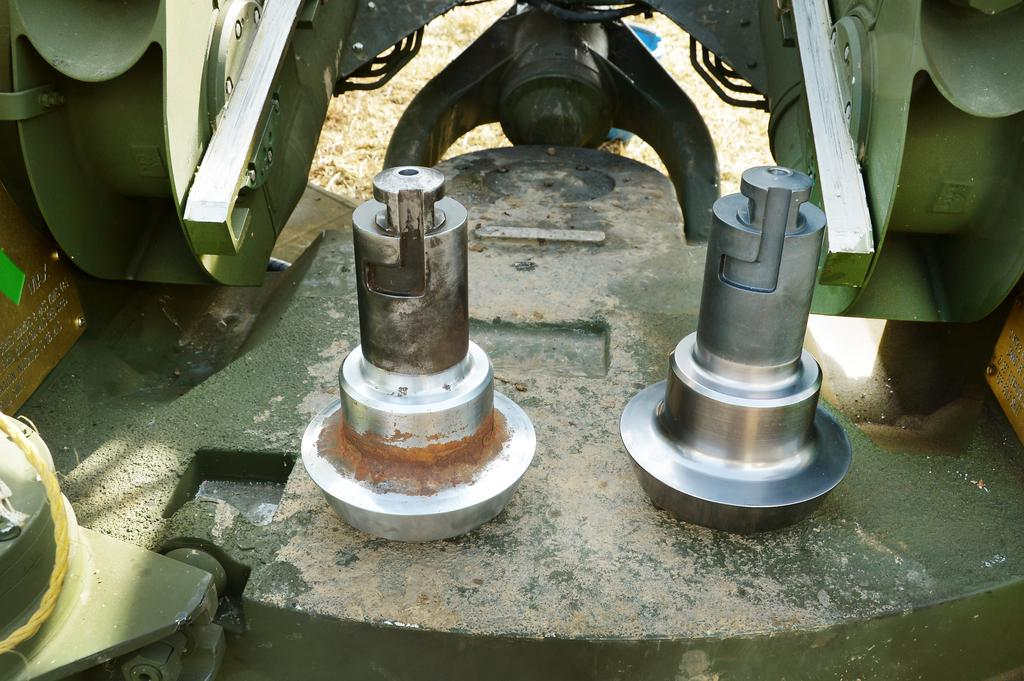What is the main subject of the image? The main subject of the image is a machine. Can you describe the machine's appearance in the image? The machine's parts are visible in the image. Where is the machine located in the image? The machine and its parts are kept on the ground. How many eggs are being used by the woman near the coast in the image? There is no woman or coast present in the image, and therefore no eggs or their usage can be observed. 